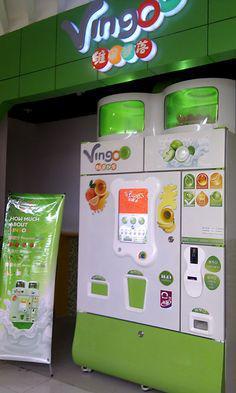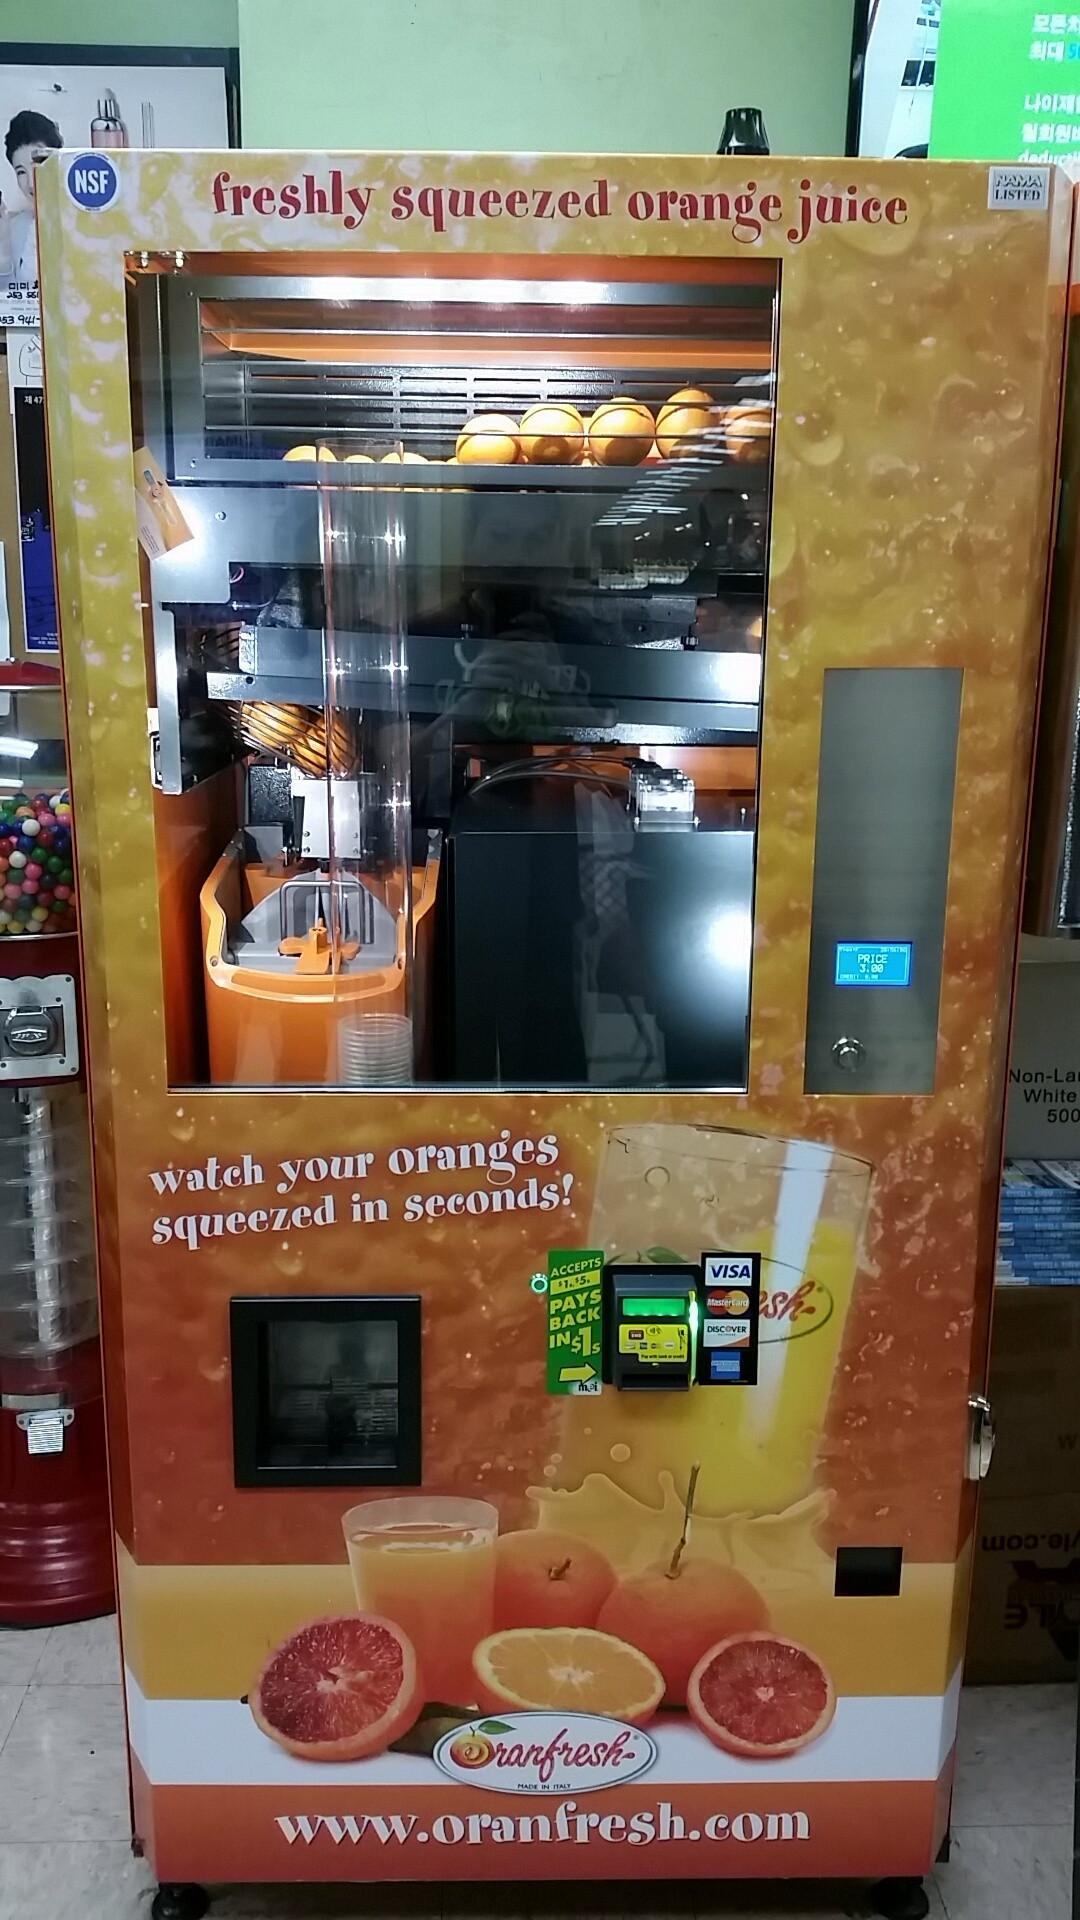The first image is the image on the left, the second image is the image on the right. Assess this claim about the two images: "A human is standing next to a vending machine in one of the images.". Correct or not? Answer yes or no. No. 